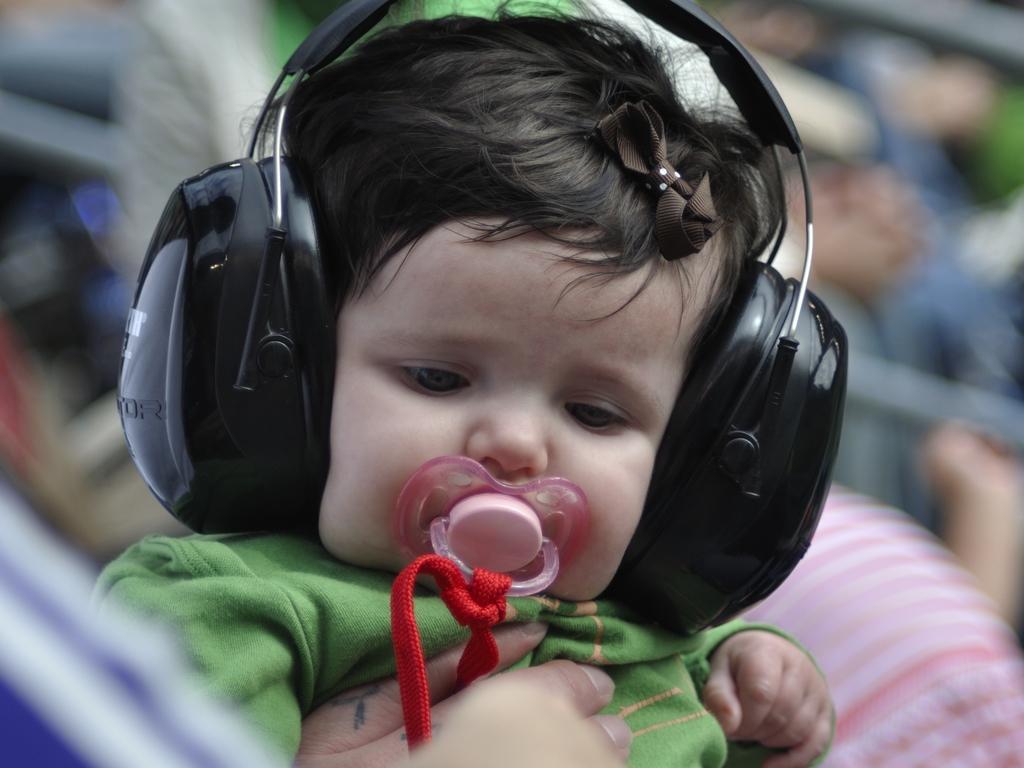Describe this image in one or two sentences. In this picture I can see there is a baby and wearing a green shirt and wearing earphones and the backdrop is blurred. 